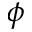<formula> <loc_0><loc_0><loc_500><loc_500>\phi</formula> 